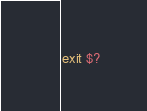<code> <loc_0><loc_0><loc_500><loc_500><_Bash_>exit $?</code> 